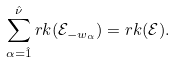Convert formula to latex. <formula><loc_0><loc_0><loc_500><loc_500>\sum _ { \alpha = \hat { 1 } } ^ { \hat { \nu } } r k ( \mathcal { E } _ { - w _ { \alpha } } ) = r k ( \mathcal { E } ) .</formula> 